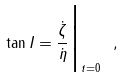Convert formula to latex. <formula><loc_0><loc_0><loc_500><loc_500>\tan I = \frac { \dot { \zeta } } { \dot { \eta } } \Big | _ { t = 0 } \ ,</formula> 